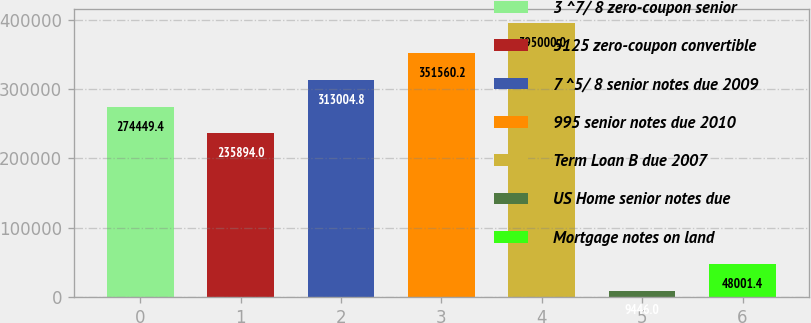<chart> <loc_0><loc_0><loc_500><loc_500><bar_chart><fcel>3 ^7/ 8 zero-coupon senior<fcel>5125 zero-coupon convertible<fcel>7 ^5/ 8 senior notes due 2009<fcel>995 senior notes due 2010<fcel>Term Loan B due 2007<fcel>US Home senior notes due<fcel>Mortgage notes on land<nl><fcel>274449<fcel>235894<fcel>313005<fcel>351560<fcel>395000<fcel>9446<fcel>48001.4<nl></chart> 